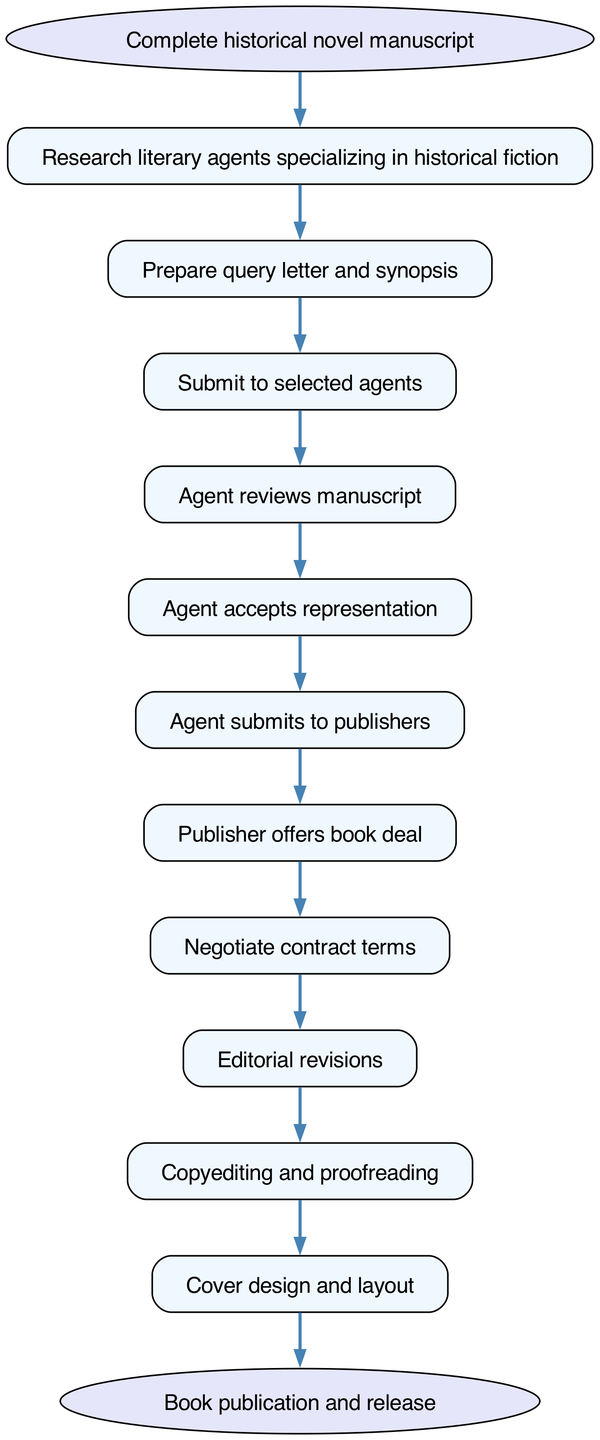What is the first step in the workflow? The diagram indicates that the first step is to "Complete historical novel manuscript." This is the starting point of the workflow.
Answer: Complete historical novel manuscript How many nodes are in the diagram? By counting the elements listed in the diagram, there are 12 nodes, including the start and end nodes.
Answer: 12 What action follows after preparing the query letter and synopsis? According to the flow, the action that follows is to "Submit to selected agents." This is the next step after preparing the necessary documents.
Answer: Submit to selected agents What happens after the publisher offers a book deal? The subsequent action is to "Negotiate contract terms," which is the step immediately following the publisher's offer.
Answer: Negotiate contract terms What is the last step in the workflow? The final step indicated in the diagram is "Book publication and release," marking the conclusion of the workflow process.
Answer: Book publication and release Which step involves editing the manuscript? The step dedicated to editing the manuscript is "Editorial revisions," where the manuscript undergoes necessary changes before further processing.
Answer: Editorial revisions How many connections are there in the diagram? The connections represent the flow from one step to another; there are 11 connections which link all nodes from start to end.
Answer: 11 Which step comes before copyediting and proofreading? Prior to "Copyediting and proofreading," the step that happens is "Editorial revisions," indicating a sequence in the editing process.
Answer: Editorial revisions What is the relationship between the agent and publishers? The relationship can be described as the agent submits the manuscript to the publishers after accepting representation. This highlights the intermediary role of the agent.
Answer: Agent submits to publishers 